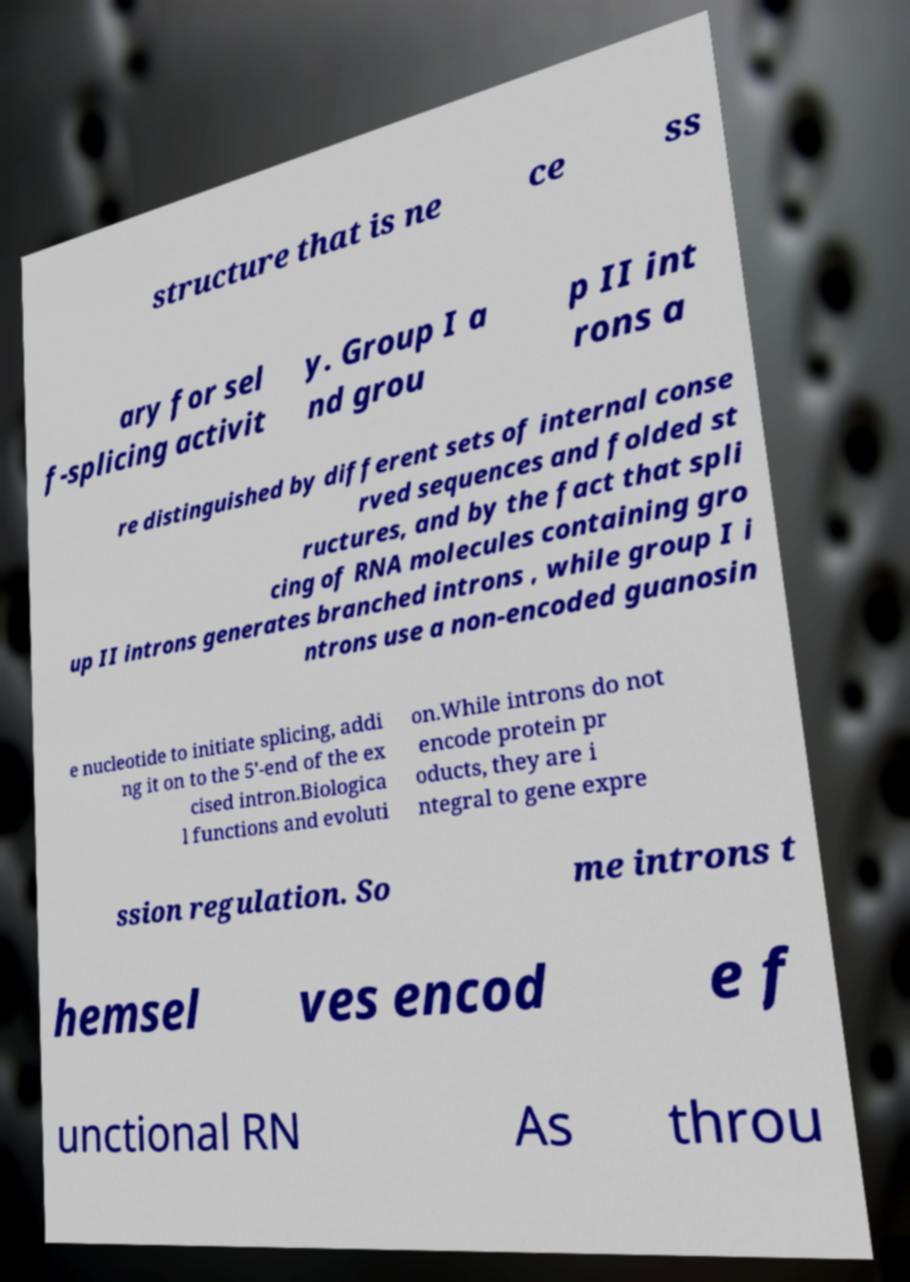Please identify and transcribe the text found in this image. structure that is ne ce ss ary for sel f-splicing activit y. Group I a nd grou p II int rons a re distinguished by different sets of internal conse rved sequences and folded st ructures, and by the fact that spli cing of RNA molecules containing gro up II introns generates branched introns , while group I i ntrons use a non-encoded guanosin e nucleotide to initiate splicing, addi ng it on to the 5'-end of the ex cised intron.Biologica l functions and evoluti on.While introns do not encode protein pr oducts, they are i ntegral to gene expre ssion regulation. So me introns t hemsel ves encod e f unctional RN As throu 